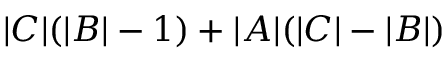<formula> <loc_0><loc_0><loc_500><loc_500>| C | ( | B | - 1 ) + | A | ( | C | - | B | )</formula> 